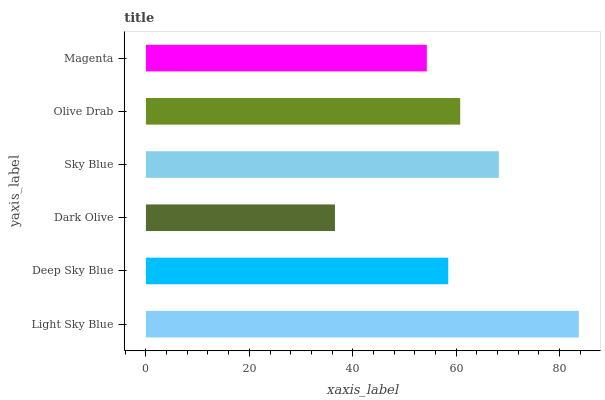Is Dark Olive the minimum?
Answer yes or no. Yes. Is Light Sky Blue the maximum?
Answer yes or no. Yes. Is Deep Sky Blue the minimum?
Answer yes or no. No. Is Deep Sky Blue the maximum?
Answer yes or no. No. Is Light Sky Blue greater than Deep Sky Blue?
Answer yes or no. Yes. Is Deep Sky Blue less than Light Sky Blue?
Answer yes or no. Yes. Is Deep Sky Blue greater than Light Sky Blue?
Answer yes or no. No. Is Light Sky Blue less than Deep Sky Blue?
Answer yes or no. No. Is Olive Drab the high median?
Answer yes or no. Yes. Is Deep Sky Blue the low median?
Answer yes or no. Yes. Is Magenta the high median?
Answer yes or no. No. Is Dark Olive the low median?
Answer yes or no. No. 